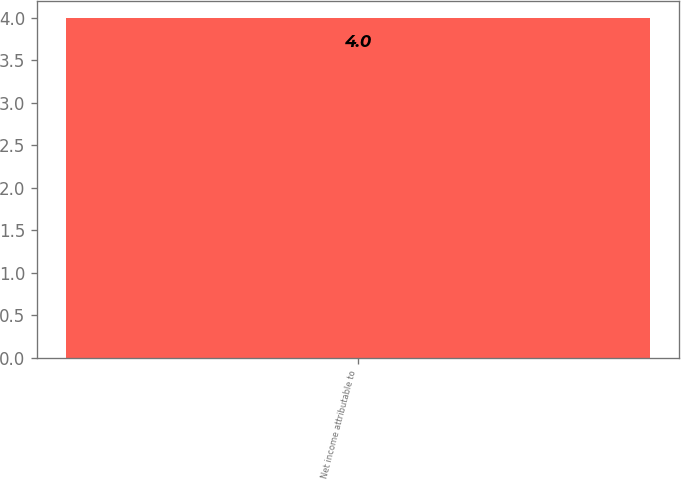<chart> <loc_0><loc_0><loc_500><loc_500><bar_chart><fcel>Net income attributable to<nl><fcel>4<nl></chart> 